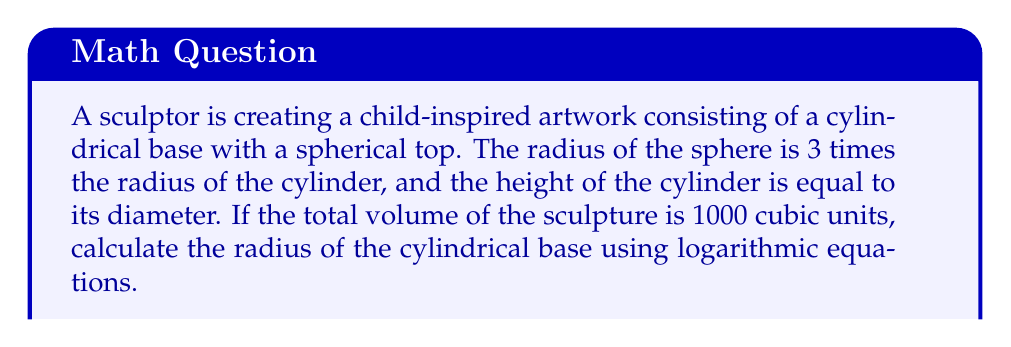Can you answer this question? Let's approach this step-by-step:

1) Let $r$ be the radius of the cylinder. Then:
   - Radius of sphere = $3r$
   - Height of cylinder = $2r$

2) Volume of cylinder: $V_c = \pi r^2 h = \pi r^2 (2r) = 2\pi r^3$

3) Volume of sphere: $V_s = \frac{4}{3}\pi (3r)^3 = 36\pi r^3$

4) Total volume: $V_t = V_c + V_s = 2\pi r^3 + 36\pi r^3 = 38\pi r^3$

5) Given that total volume is 1000 cubic units:

   $$1000 = 38\pi r^3$$

6) Divide both sides by $38\pi$:

   $$\frac{1000}{38\pi} = r^3$$

7) Take the natural logarithm of both sides:

   $$\ln(\frac{1000}{38\pi}) = \ln(r^3) = 3\ln(r)$$

8) Divide both sides by 3:

   $$\frac{1}{3}\ln(\frac{1000}{38\pi}) = \ln(r)$$

9) Take the exponential of both sides:

   $$r = e^{\frac{1}{3}\ln(\frac{1000}{38\pi})}$$

10) Calculate the value:

    $$r \approx 2.9934$$
Answer: $r = e^{\frac{1}{3}\ln(\frac{1000}{38\pi})} \approx 2.9934$ units 